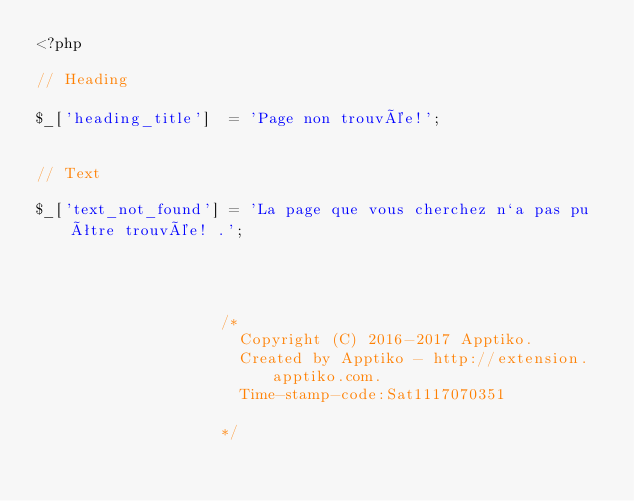<code> <loc_0><loc_0><loc_500><loc_500><_PHP_><?php

// Heading

$_['heading_title']  = 'Page non trouvée!';


// Text

$_['text_not_found'] = 'La page que vous cherchez n`a pas pu être trouvée! .';




					/* 
					  Copyright (C) 2016-2017 Apptiko.
					  Created by Apptiko - http://extension.apptiko.com.
					  Time-stamp-code:Sat1117070351					  
					*/</code> 